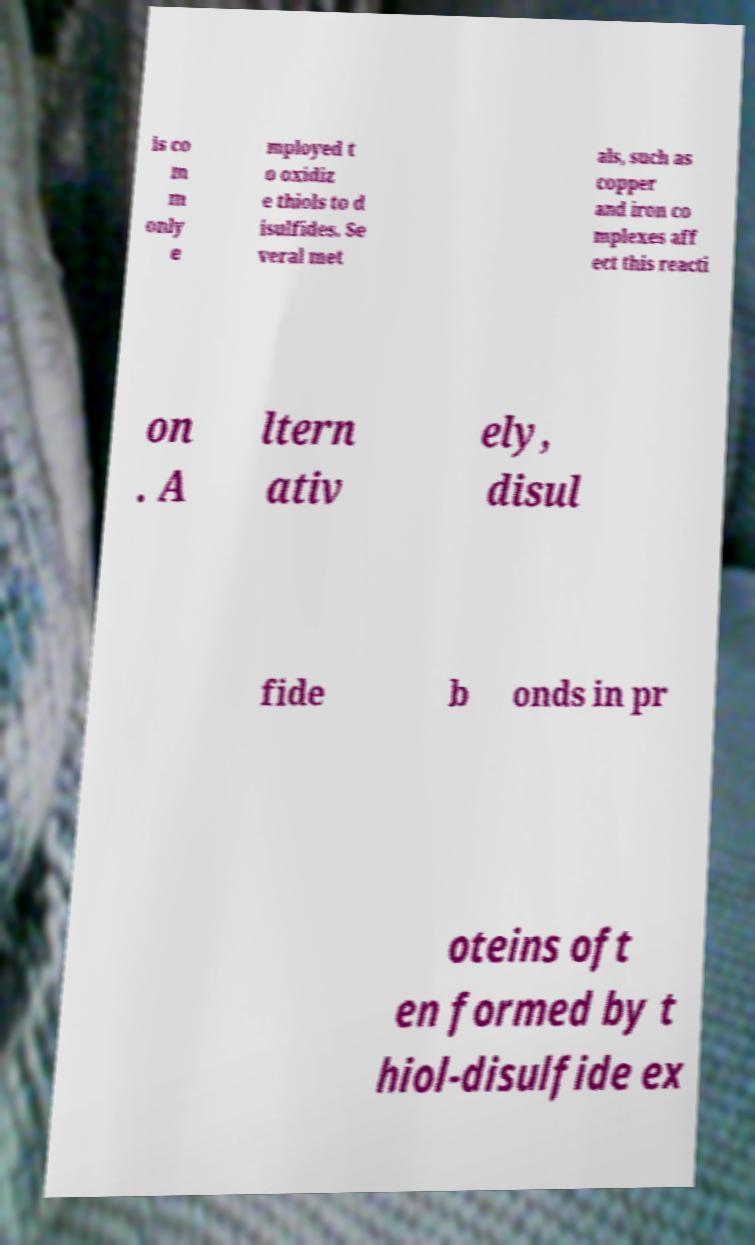What messages or text are displayed in this image? I need them in a readable, typed format. is co m m only e mployed t o oxidiz e thiols to d isulfides. Se veral met als, such as copper and iron co mplexes aff ect this reacti on . A ltern ativ ely, disul fide b onds in pr oteins oft en formed by t hiol-disulfide ex 